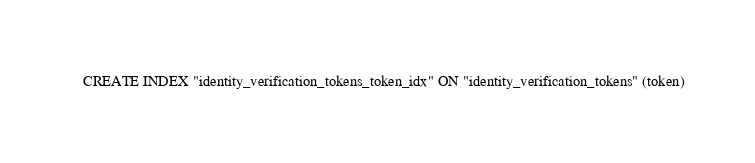Convert code to text. <code><loc_0><loc_0><loc_500><loc_500><_SQL_>CREATE INDEX "identity_verification_tokens_token_idx" ON "identity_verification_tokens" (token)</code> 